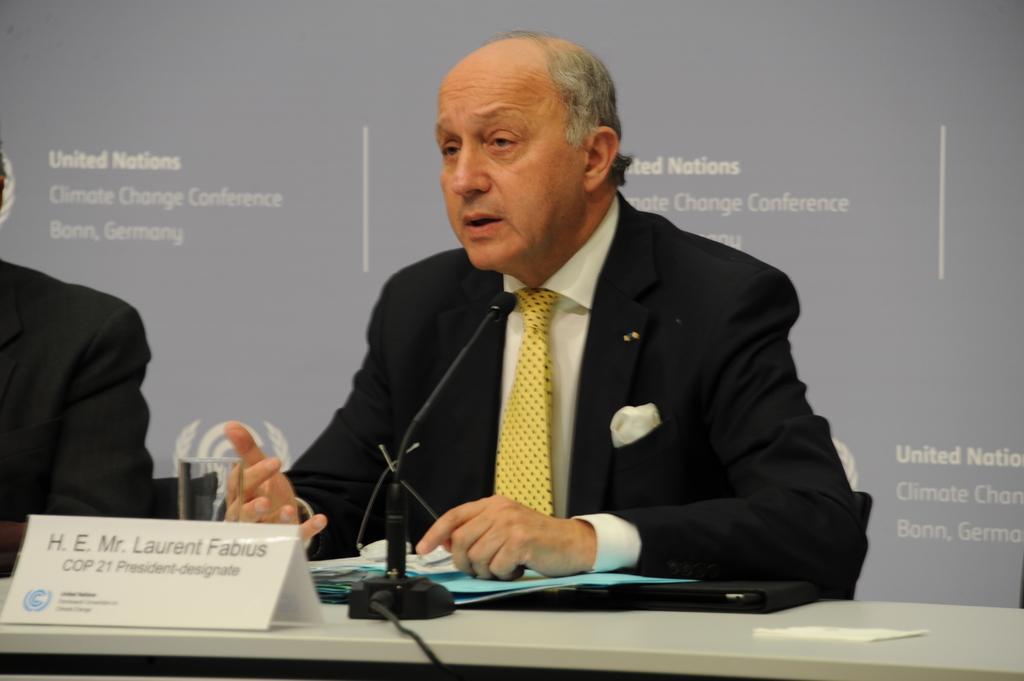Could you give a brief overview of what you see in this image? In this image we can see a person sitting. In front of the person we can see a mic, files and a board with text on a table. On the left side, we can see another person. Behind the persons we can see a banner with text. 